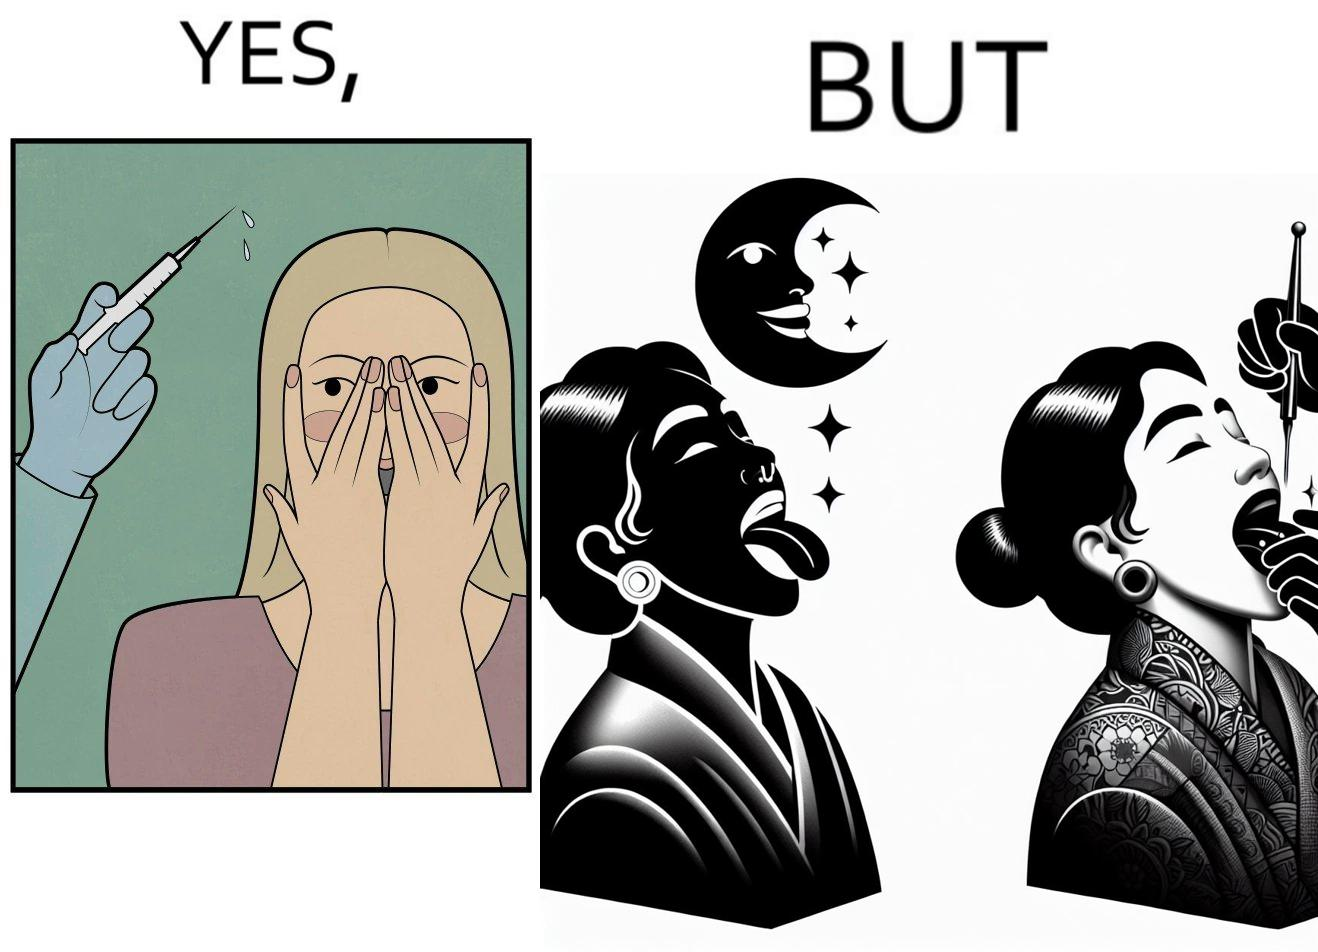Describe what you see in the left and right parts of this image. In the left part of the image: The iamge shows a woman scared of the syringe about to be used to inject her with medicine. In the right part of the image: The image shows a woman with her tongue out getting a piercing in her tongue. The image also shows shows the same woman getting tattoed on her left arm at the same time as getting  a piercing. 